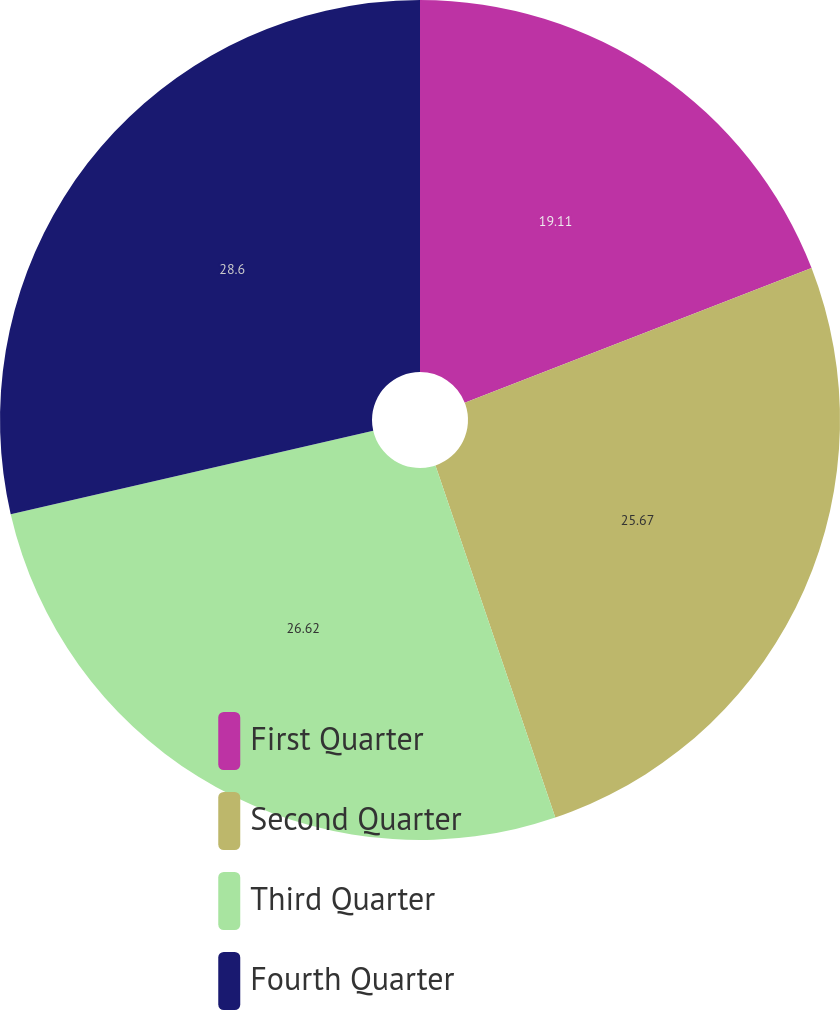Convert chart. <chart><loc_0><loc_0><loc_500><loc_500><pie_chart><fcel>First Quarter<fcel>Second Quarter<fcel>Third Quarter<fcel>Fourth Quarter<nl><fcel>19.11%<fcel>25.67%<fcel>26.62%<fcel>28.6%<nl></chart> 